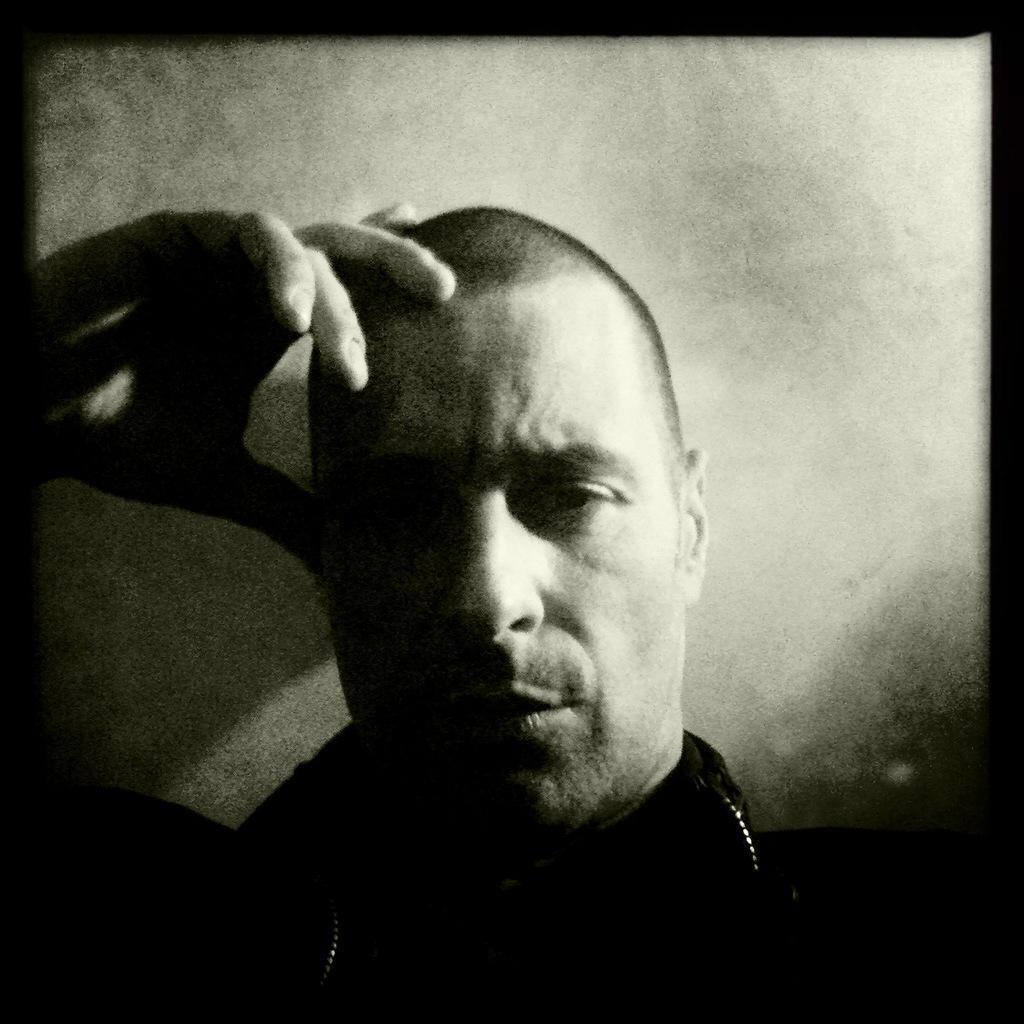Describe this image in one or two sentences. In this image we can see a person with white background. 